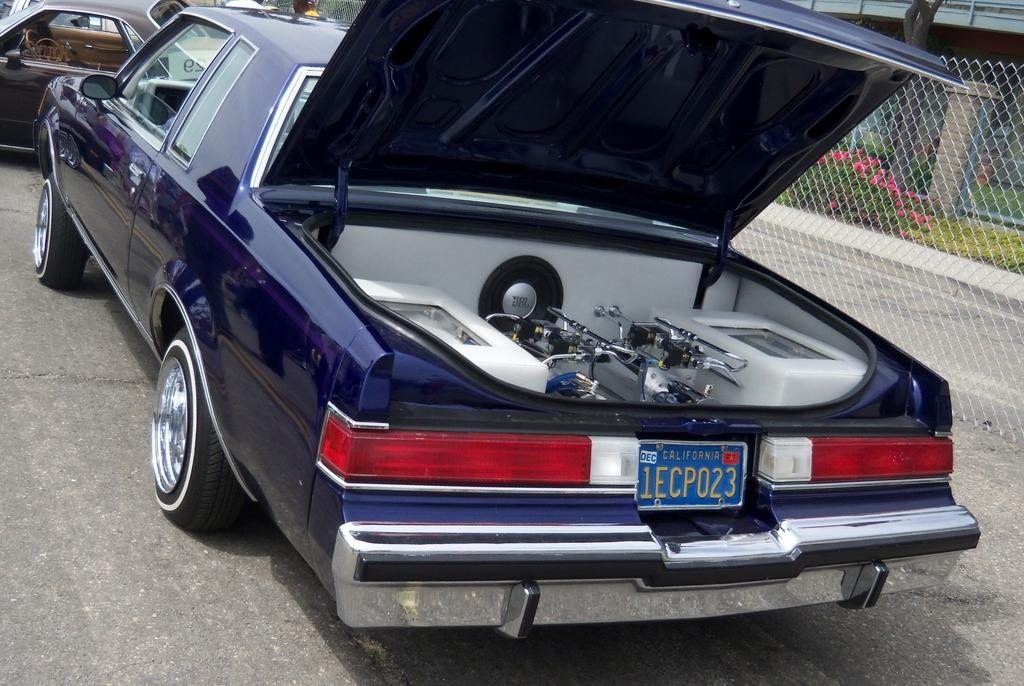<image>
Present a compact description of the photo's key features. Purple car with the license plate 1ECP023 on it. 